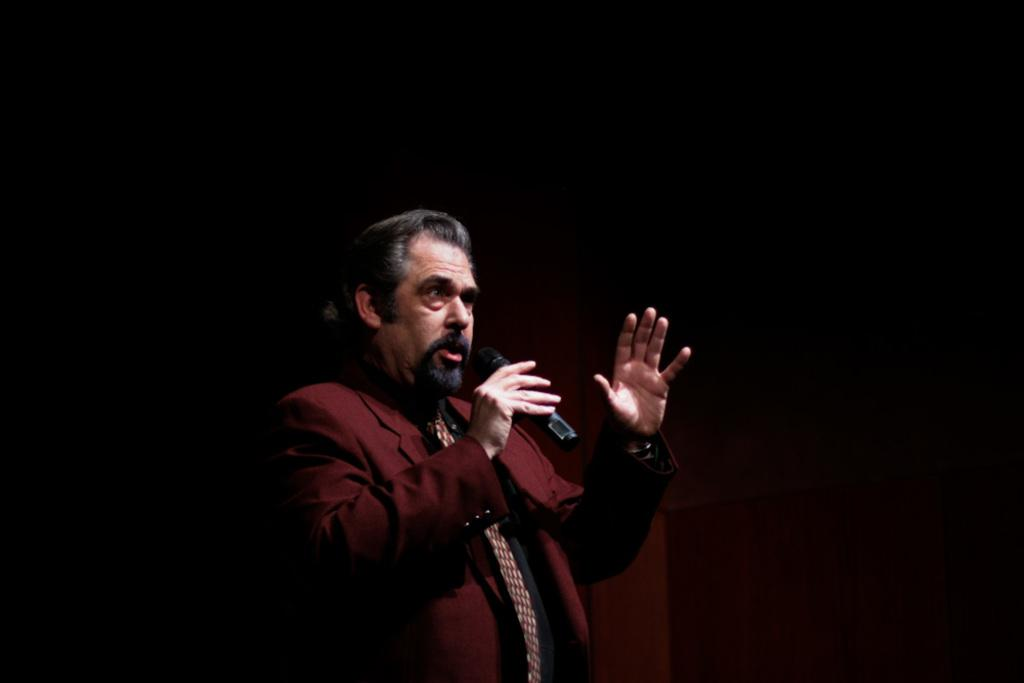What is the overall tone of the image? The image is dark. Can you describe the person in the image? There is a man in the image. What is the man wearing? The man is wearing a suit. What is the man holding in his right hand? The man is holding a microphone in his right hand. What is the man doing in the image? The man is speaking. Can you tell me how many cats are sitting on the scale in the image? There are no cats or scales present in the image. What rule is the man breaking in the image? There is no indication of any rule being broken in the image. 